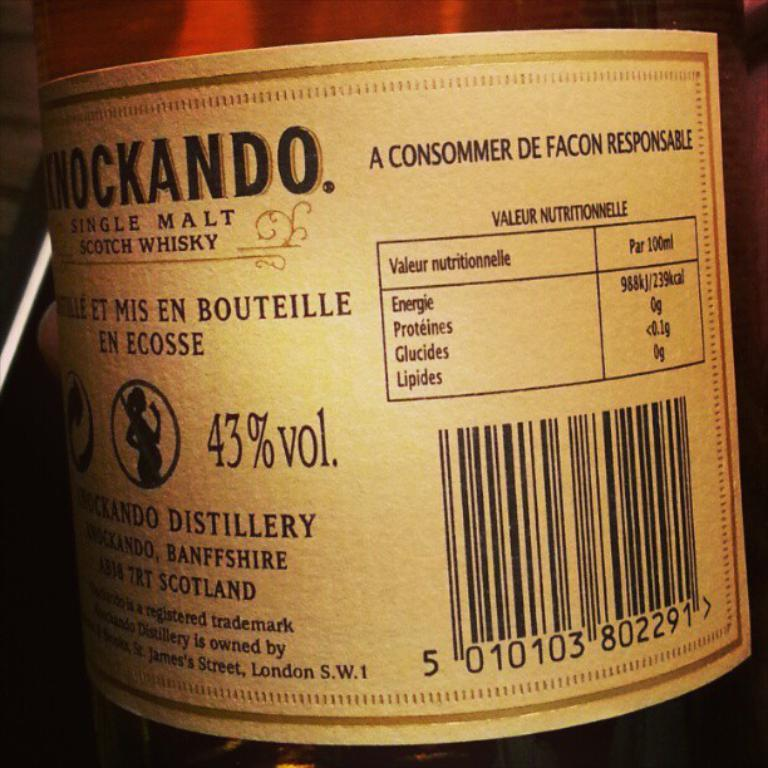<image>
Provide a brief description of the given image. A scotch whisky lable shows an alcohol content of 43%. 